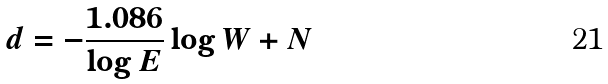Convert formula to latex. <formula><loc_0><loc_0><loc_500><loc_500>d = - \frac { 1 . 0 8 6 } { \log E } \log W + N</formula> 